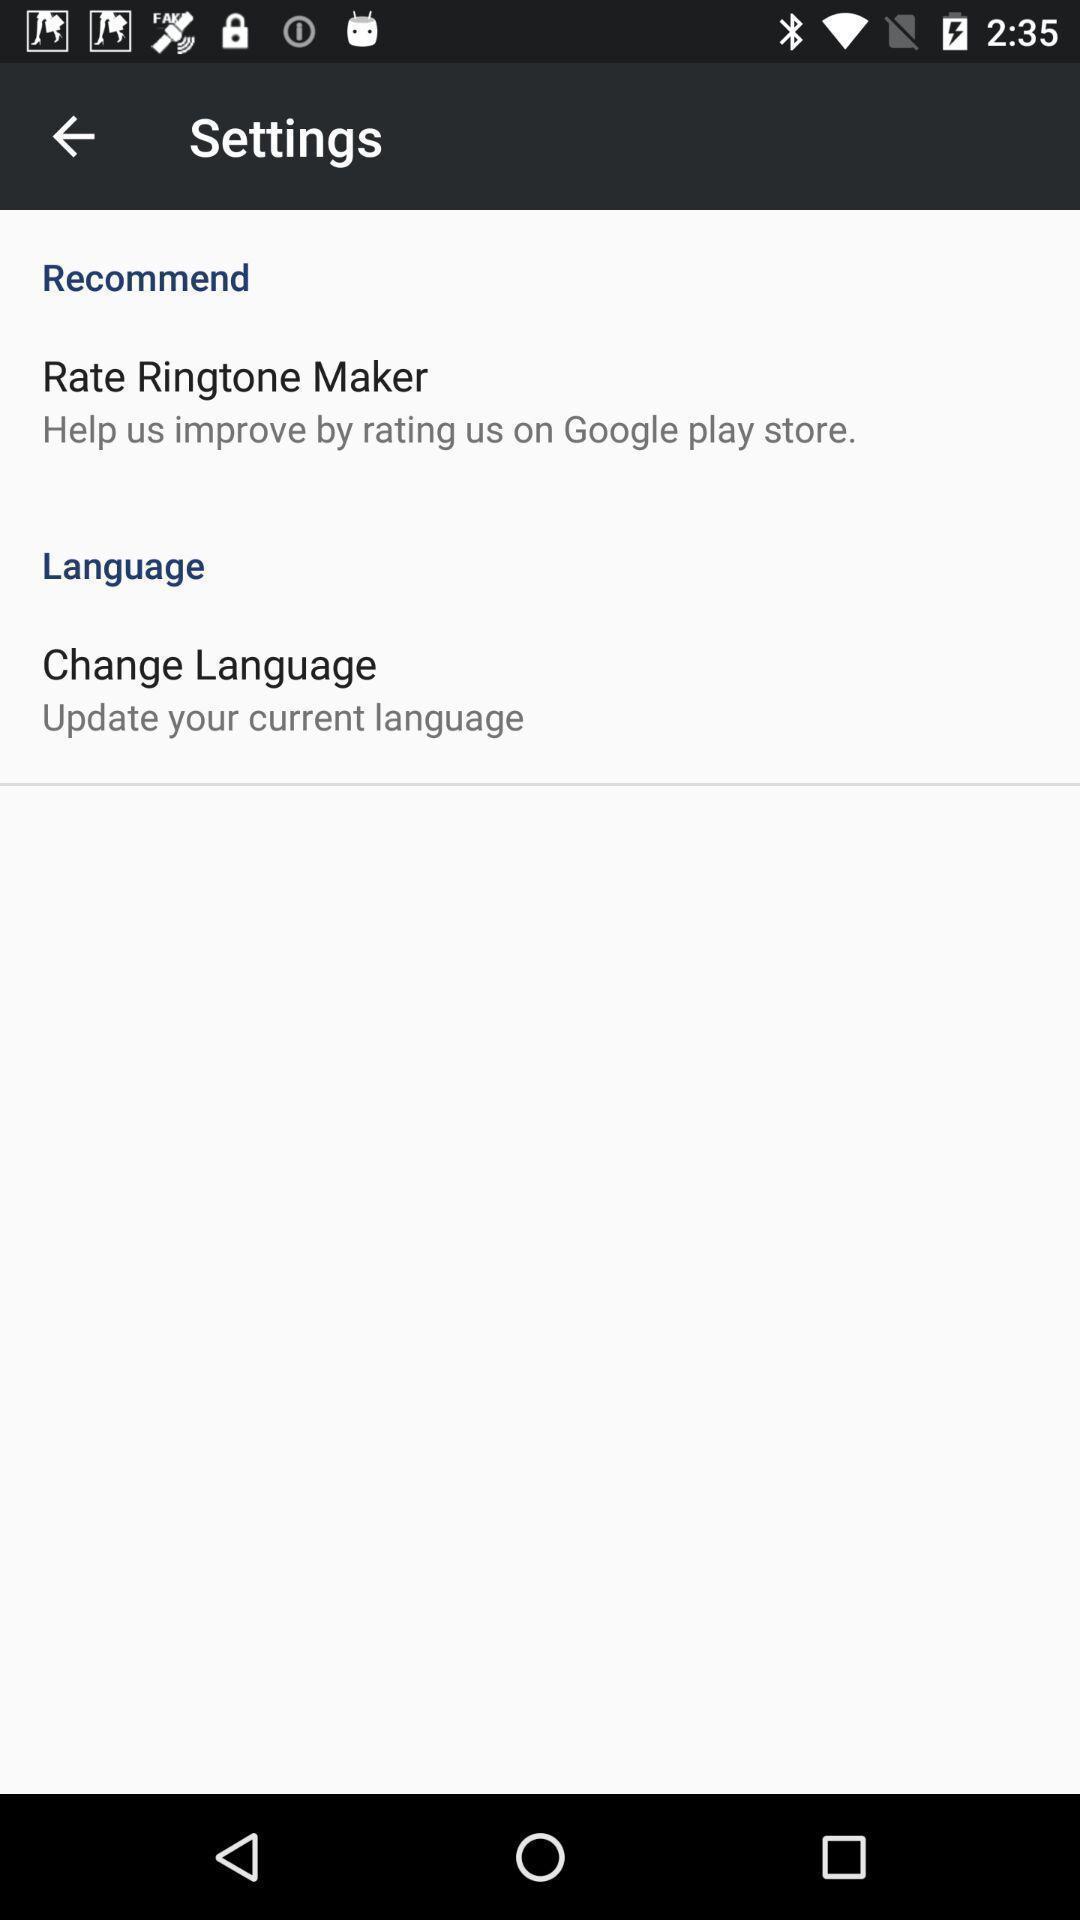Provide a detailed account of this screenshot. Screen shows settings. 